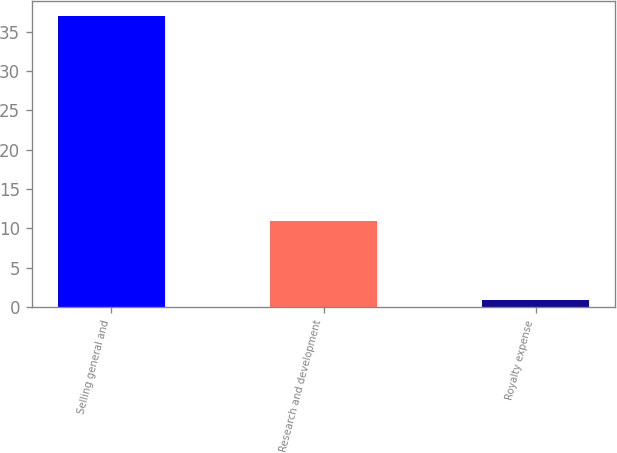Convert chart to OTSL. <chart><loc_0><loc_0><loc_500><loc_500><bar_chart><fcel>Selling general and<fcel>Research and development<fcel>Royalty expense<nl><fcel>37<fcel>11<fcel>0.9<nl></chart> 